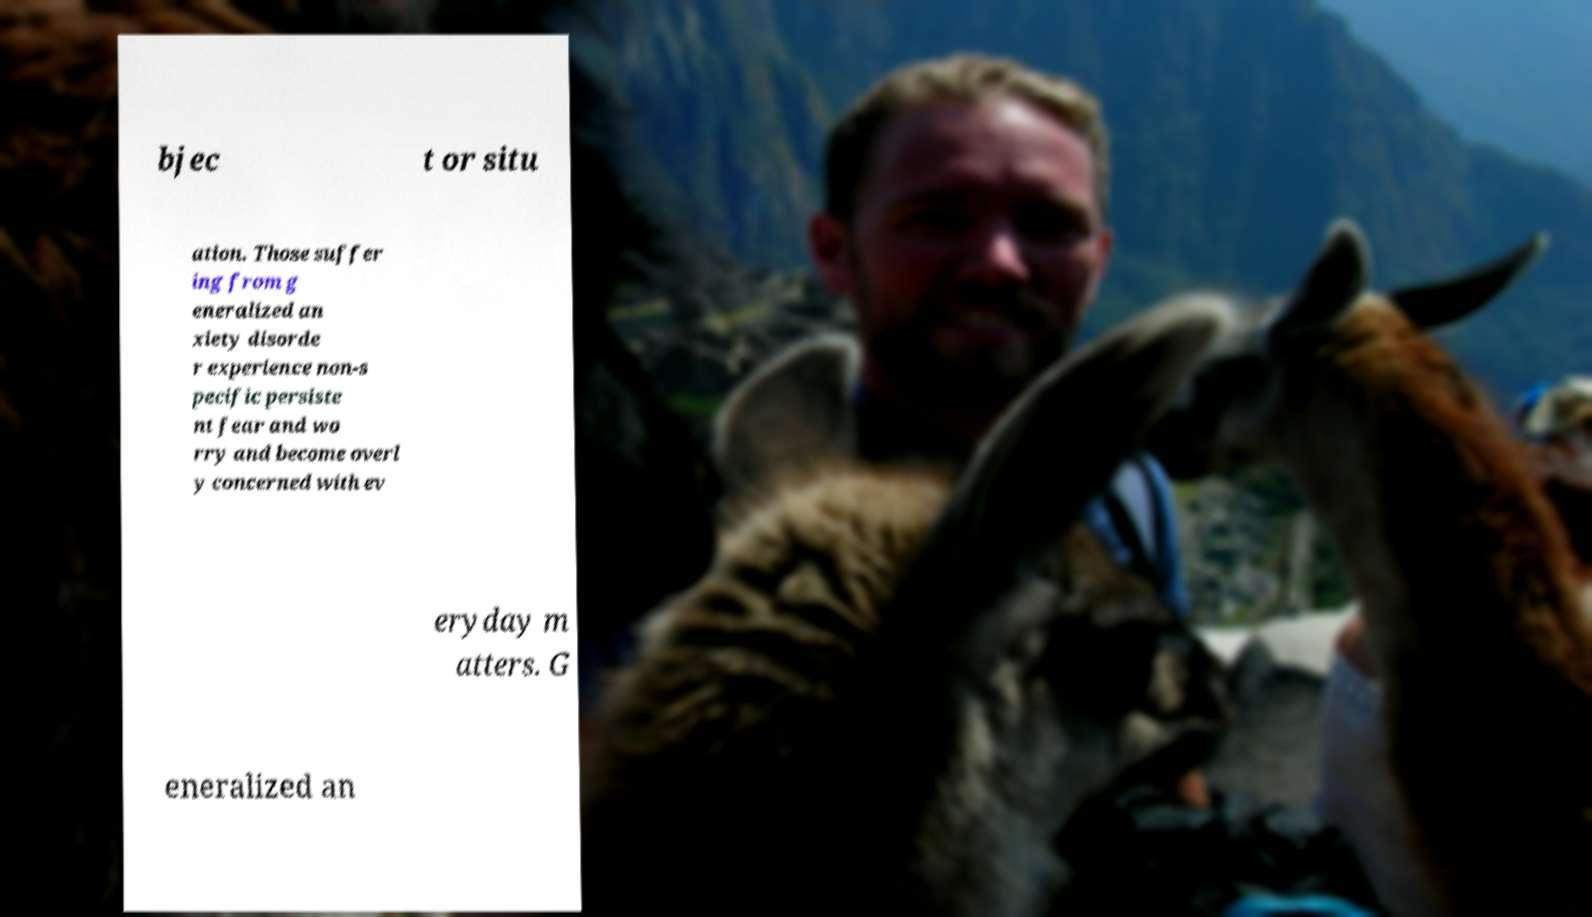Please identify and transcribe the text found in this image. bjec t or situ ation. Those suffer ing from g eneralized an xiety disorde r experience non-s pecific persiste nt fear and wo rry and become overl y concerned with ev eryday m atters. G eneralized an 